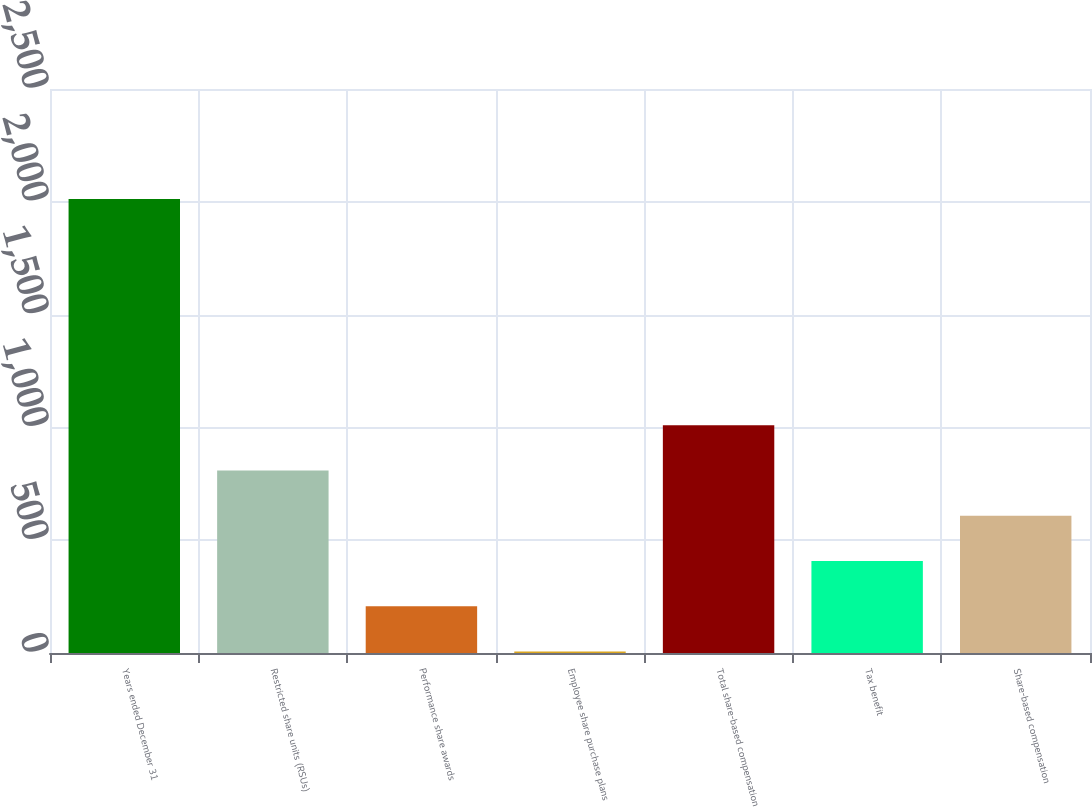Convert chart to OTSL. <chart><loc_0><loc_0><loc_500><loc_500><bar_chart><fcel>Years ended December 31<fcel>Restricted share units (RSUs)<fcel>Performance share awards<fcel>Employee share purchase plans<fcel>Total share-based compensation<fcel>Tax benefit<fcel>Share-based compensation<nl><fcel>2012<fcel>809<fcel>207.5<fcel>7<fcel>1009.5<fcel>408<fcel>608.5<nl></chart> 